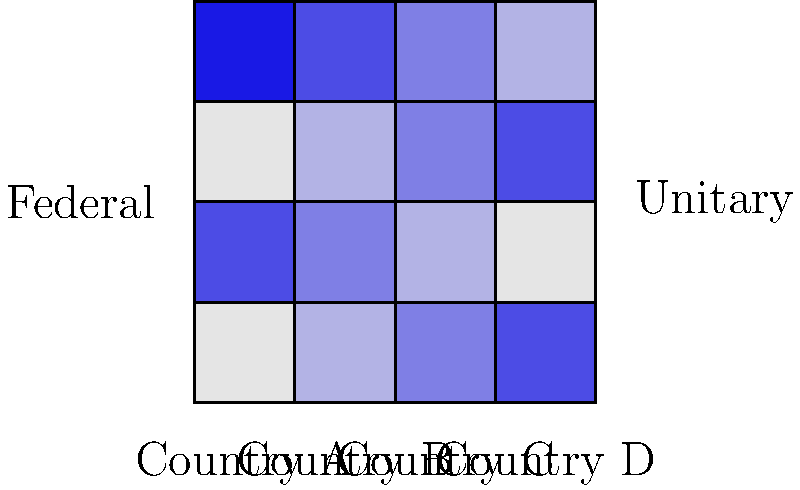The choropleth map above represents regional economic disparities in four countries, two with federal systems (left) and two with unitary systems (right). Darker shades indicate higher levels of economic development. Based on this visualization, which type of political system appears to be associated with more balanced regional economic development, and why might this be the case? To answer this question, we need to analyze the patterns of economic development across regions in federal and unitary systems:

1. Federal systems (left side of the map):
   - Country A shows high variation in economic development across regions.
   - Country C shows moderate variation, but still noticeable differences.

2. Unitary systems (right side of the map):
   - Country B shows relatively uniform economic development across regions.
   - Country D shows some variation, but less pronounced than in federal systems.

3. Comparison:
   - Federal systems (A and C) display more significant regional disparities.
   - Unitary systems (B and D) show more balanced economic development across regions.

4. Potential explanations:
   - Unitary systems often have centralized economic policies, which may lead to more even distribution of resources and development initiatives.
   - Federal systems give more autonomy to regions, which can result in some regions outperforming others based on local policies and resources.
   - Centralized governance in unitary systems may be better equipped to implement nationwide development strategies.
   - Federal systems might struggle with coordinating economic policies across diverse regions.

5. Implications for political institutions:
   - This visualization suggests that the type of political system (federal vs. unitary) can influence economic outcomes, specifically in terms of regional economic disparities.
   - It supports the argument that political institutions have a significant impact on economic development patterns.

Based on this analysis, the unitary system appears to be associated with more balanced regional economic development.
Answer: Unitary system; centralized economic policies promote more even development across regions. 